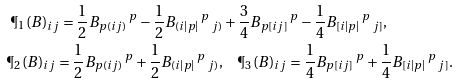Convert formula to latex. <formula><loc_0><loc_0><loc_500><loc_500>\P _ { 1 } ( B ) _ { i j } = \frac { 1 } { 2 } B _ { p ( i j ) } \, ^ { p } - \frac { 1 } { 2 } B _ { ( i | p | } \, ^ { p } \, _ { j ) } & + \frac { 3 } { 4 } B _ { p [ i j ] } \, ^ { p } - \frac { 1 } { 4 } B _ { [ i | p | } \, ^ { p } \, _ { j ] } , \\ \P _ { 2 } ( B ) _ { i j } = \frac { 1 } { 2 } B _ { p ( i j ) } \, ^ { p } + \frac { 1 } { 2 } B _ { ( i | p | } \, ^ { p } \, _ { j ) } , & \quad \P _ { 3 } ( B ) _ { i j } = \frac { 1 } { 4 } B _ { p [ i j ] } \, ^ { p } + \frac { 1 } { 4 } B _ { [ i | p | } \, ^ { p } \, _ { j ] } .</formula> 